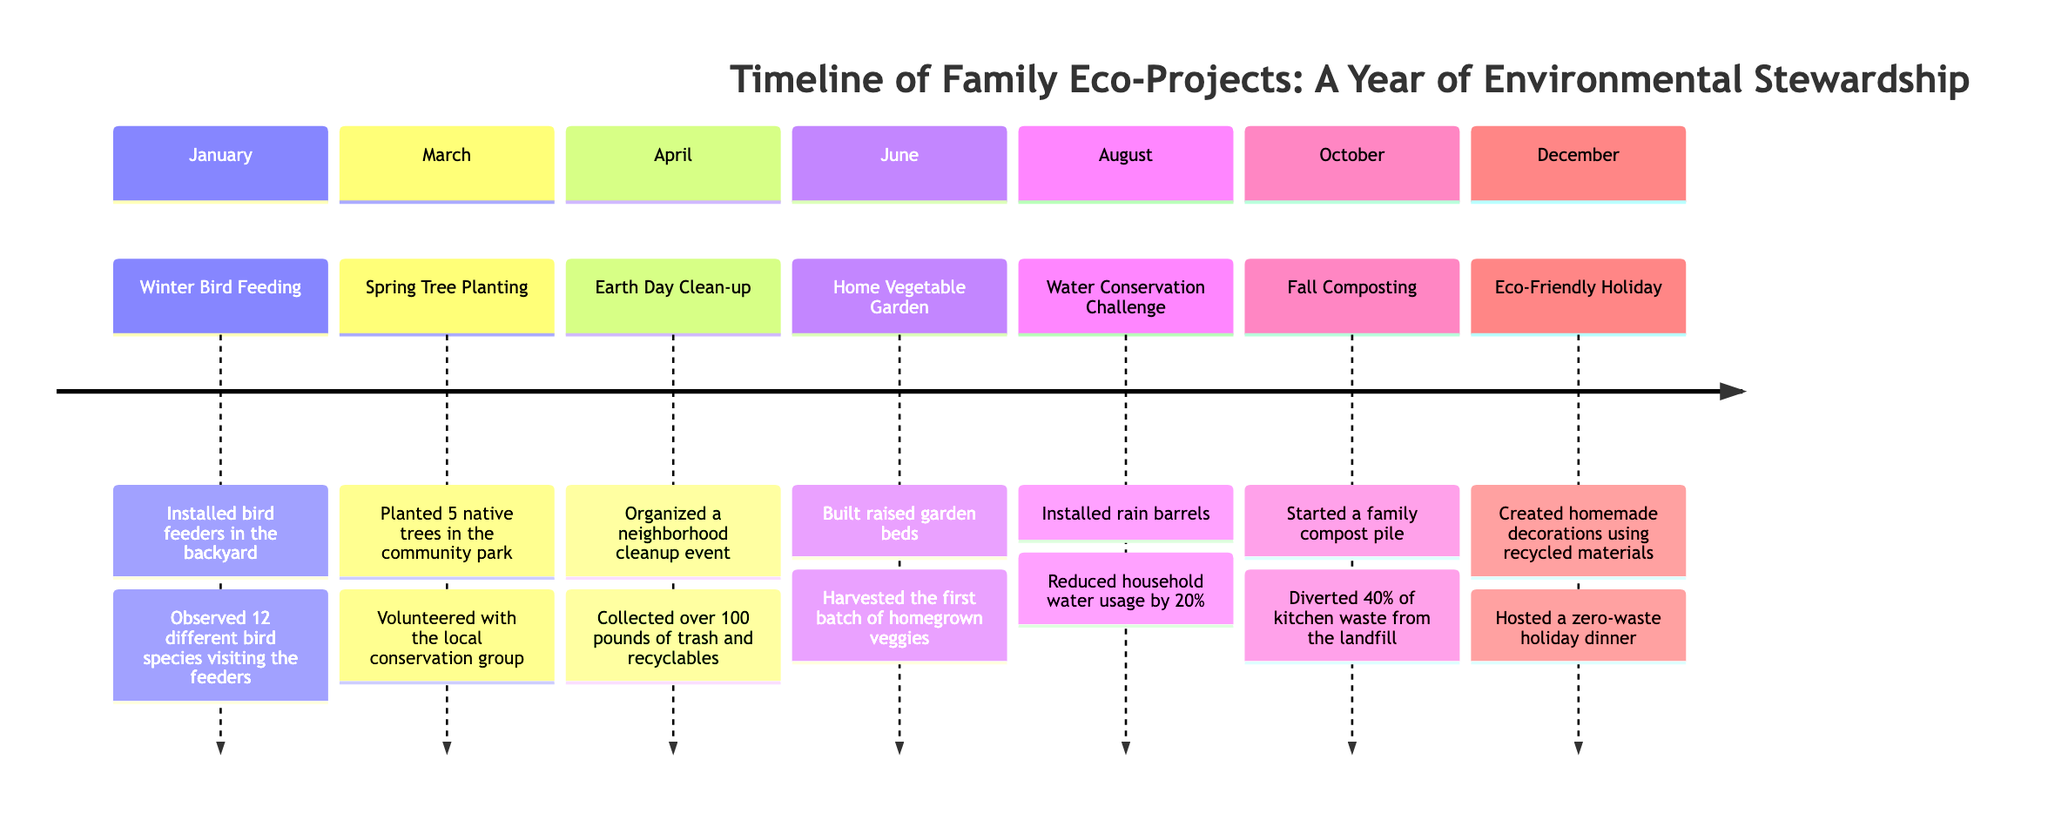What project was completed in January? The diagram lists "Winter Bird Feeding" as the project for January.
Answer: Winter Bird Feeding How many native trees were planted in March? According to the diagram, 5 native trees were planted during the project in March.
Answer: 5 What was the achievement in April? The diagram states that in April, the achievement was "Collected over 100 pounds of trash and recyclables" during the Earth Day Clean-up project.
Answer: Collected over 100 pounds of trash and recyclables What was achieved in August? The diagram specifies that in August, the household water usage was reduced by 20% during the Water Conservation Challenge.
Answer: Reduced household water usage by 20% How many different bird species visited the feeders in January? The timeline indicates that 12 different bird species were observed visiting the feeders during the Winter Bird Feeding project.
Answer: 12 Which project included the installation of rain barrels? The timeline specifies that rain barrels were installed as part of the Water Conservation Challenge project in August.
Answer: Water Conservation Challenge What was the milestone achieved in October? In October, the diagram states the milestone was "Started a family compost pile" for the Fall Composting project.
Answer: Started a family compost pile What did the family host during the Eco-Friendly Holiday in December? The diagram mentions that during the Eco-Friendly Holiday project, the family hosted a zero-waste holiday dinner.
Answer: Hosted a zero-waste holiday dinner Which project involved building raised garden beds? The Home Vegetable Garden project in June included the milestone of building raised garden beds according to the diagram.
Answer: Home Vegetable Garden 